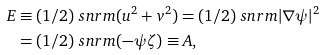<formula> <loc_0><loc_0><loc_500><loc_500>E & \equiv ( 1 / 2 ) \ s n r m { ( u ^ { 2 } + v ^ { 2 } ) } = ( 1 / 2 ) \ s n r m { | \nabla \psi | ^ { 2 } } \\ & = ( 1 / 2 ) \ s n r m { ( - \psi \zeta ) } \equiv A ,</formula> 